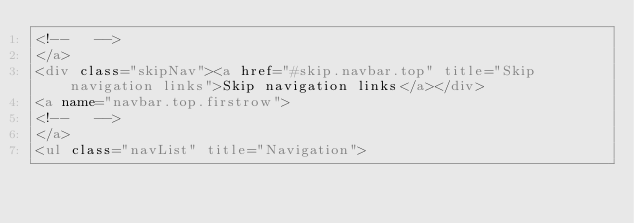Convert code to text. <code><loc_0><loc_0><loc_500><loc_500><_HTML_><!--   -->
</a>
<div class="skipNav"><a href="#skip.navbar.top" title="Skip navigation links">Skip navigation links</a></div>
<a name="navbar.top.firstrow">
<!--   -->
</a>
<ul class="navList" title="Navigation"></code> 